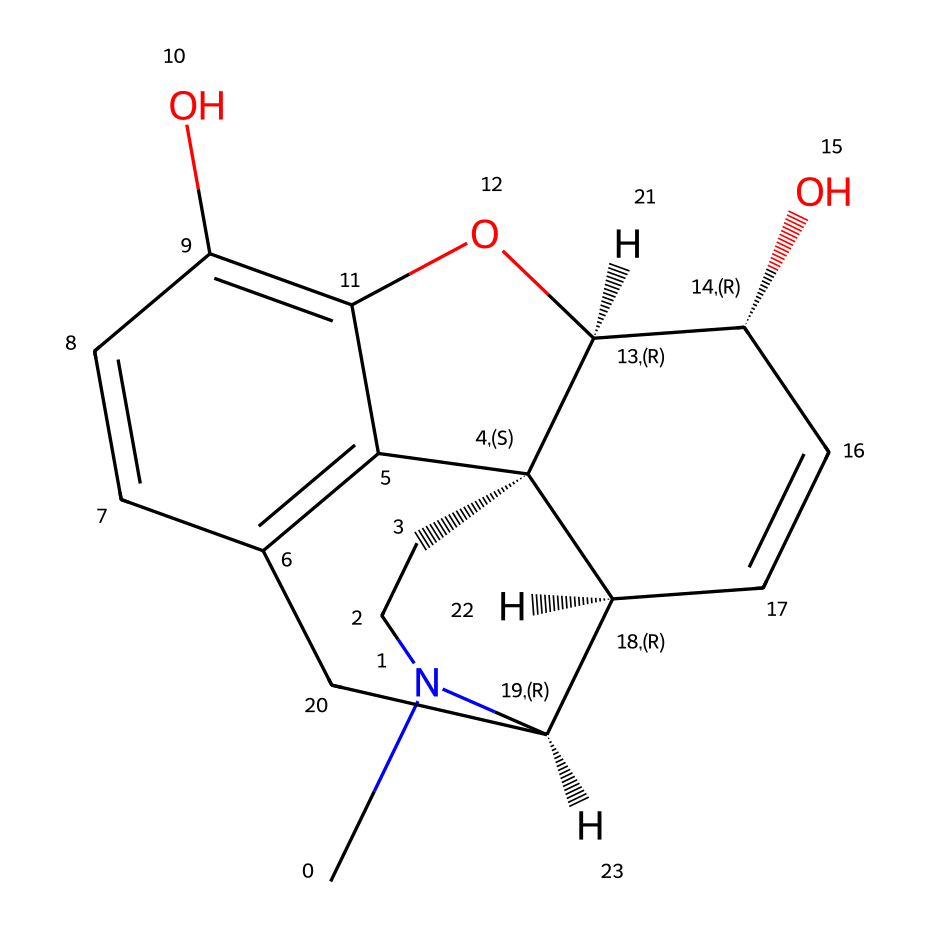What is the molecular formula of morphine based on the SMILES? To derive the molecular formula from the SMILES representation, count the number of each atom represented in the SMILES string. For morphine, it consists of 17 carbons, 19 hydrogens, 1 nitrogen, and 3 oxygens, leading to the molecular formula C17H19N1O3.
Answer: C17H19N1O3 How many rings are present in the morphine structure? By examining the cyclic portions of the SMILES, we can identify the number of rings. Morphine has five rings in its structure, which helps define its complex shape and properties.
Answer: 5 What functional groups are present in morphine? The structural representation highlights hydroxyl groups (-OH) and the nitrogen atom as key functional groups. Morphine specifically has two hydroxyl functional groups and an amine group due to the nitrogen.
Answer: two hydroxyls and one amine Does morphine contain any chiral centers? To determine chirality, examine the carbon atoms connected to four distinct substituents. In the case of morphine, there are five chiral centers, seen by identifying the appropriate carbon atoms in the structure.
Answer: five What type of chemical is morphine classified as? Morphine fits the classification of alkaloids primarily due to the presence of nitrogen and its plant-derived origins. Alkaloids are characterized by their basic nature and potential biological activity.
Answer: alkaloid What is the main medical use of morphine? Morphine is primarily used as an analgesic for pain management, which is crucial for performers and artists requiring pain relief for better performance. This known property underscores its significance in medicine.
Answer: pain management 